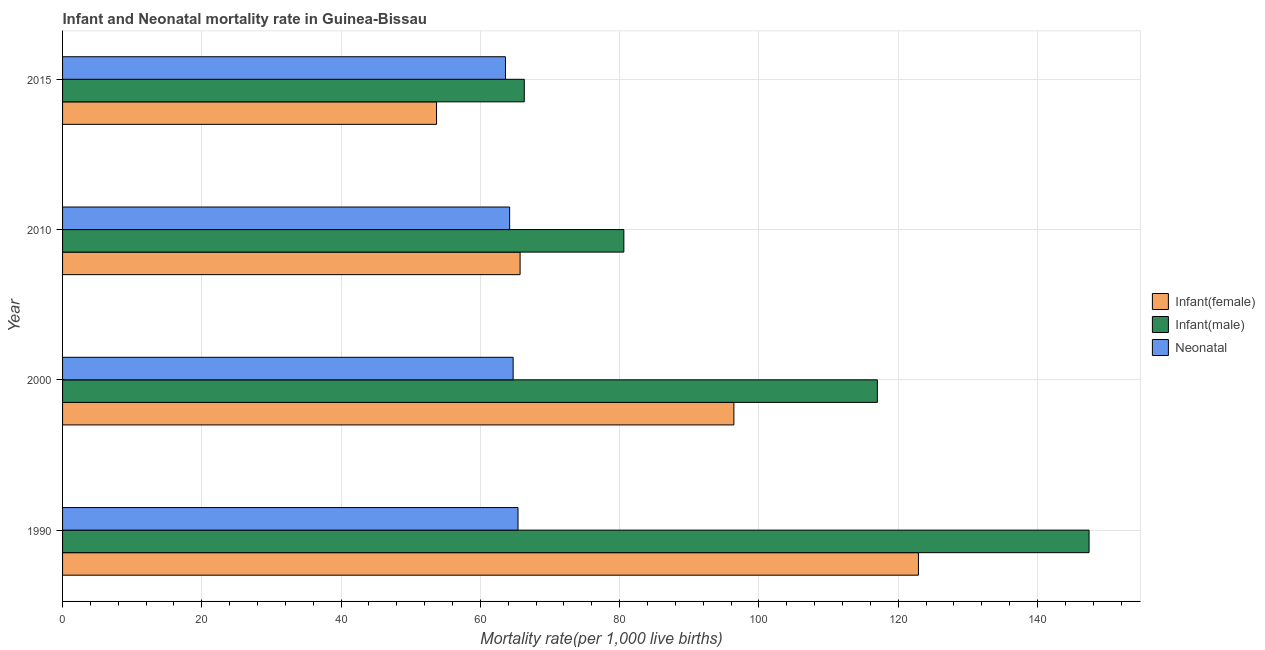How many different coloured bars are there?
Keep it short and to the point. 3. Are the number of bars on each tick of the Y-axis equal?
Provide a succinct answer. Yes. In how many cases, is the number of bars for a given year not equal to the number of legend labels?
Provide a succinct answer. 0. What is the neonatal mortality rate in 2010?
Your response must be concise. 64.2. Across all years, what is the maximum infant mortality rate(female)?
Keep it short and to the point. 122.9. Across all years, what is the minimum infant mortality rate(male)?
Keep it short and to the point. 66.3. In which year was the infant mortality rate(female) minimum?
Offer a very short reply. 2015. What is the total infant mortality rate(male) in the graph?
Give a very brief answer. 411.3. What is the difference between the infant mortality rate(male) in 1990 and that in 2000?
Your answer should be compact. 30.4. What is the difference between the infant mortality rate(male) in 1990 and the neonatal mortality rate in 2000?
Your response must be concise. 82.7. What is the average infant mortality rate(female) per year?
Provide a short and direct response. 84.67. In the year 2000, what is the difference between the neonatal mortality rate and infant mortality rate(male)?
Your response must be concise. -52.3. What is the ratio of the infant mortality rate(male) in 1990 to that in 2010?
Offer a very short reply. 1.83. Is the infant mortality rate(male) in 1990 less than that in 2010?
Your response must be concise. No. What is the difference between the highest and the lowest infant mortality rate(male)?
Make the answer very short. 81.1. In how many years, is the infant mortality rate(male) greater than the average infant mortality rate(male) taken over all years?
Make the answer very short. 2. What does the 1st bar from the top in 2010 represents?
Offer a very short reply. Neonatal . What does the 3rd bar from the bottom in 2000 represents?
Ensure brevity in your answer.  Neonatal . How many bars are there?
Your answer should be compact. 12. Are the values on the major ticks of X-axis written in scientific E-notation?
Offer a very short reply. No. Does the graph contain any zero values?
Offer a very short reply. No. Does the graph contain grids?
Keep it short and to the point. Yes. What is the title of the graph?
Ensure brevity in your answer.  Infant and Neonatal mortality rate in Guinea-Bissau. What is the label or title of the X-axis?
Your answer should be compact. Mortality rate(per 1,0 live births). What is the Mortality rate(per 1,000 live births) of Infant(female) in 1990?
Offer a very short reply. 122.9. What is the Mortality rate(per 1,000 live births) in Infant(male) in 1990?
Give a very brief answer. 147.4. What is the Mortality rate(per 1,000 live births) in Neonatal  in 1990?
Provide a short and direct response. 65.4. What is the Mortality rate(per 1,000 live births) in Infant(female) in 2000?
Your response must be concise. 96.4. What is the Mortality rate(per 1,000 live births) of Infant(male) in 2000?
Offer a terse response. 117. What is the Mortality rate(per 1,000 live births) in Neonatal  in 2000?
Make the answer very short. 64.7. What is the Mortality rate(per 1,000 live births) of Infant(female) in 2010?
Provide a succinct answer. 65.7. What is the Mortality rate(per 1,000 live births) of Infant(male) in 2010?
Your answer should be compact. 80.6. What is the Mortality rate(per 1,000 live births) of Neonatal  in 2010?
Ensure brevity in your answer.  64.2. What is the Mortality rate(per 1,000 live births) in Infant(female) in 2015?
Your answer should be compact. 53.7. What is the Mortality rate(per 1,000 live births) in Infant(male) in 2015?
Provide a succinct answer. 66.3. What is the Mortality rate(per 1,000 live births) of Neonatal  in 2015?
Make the answer very short. 63.6. Across all years, what is the maximum Mortality rate(per 1,000 live births) of Infant(female)?
Provide a succinct answer. 122.9. Across all years, what is the maximum Mortality rate(per 1,000 live births) of Infant(male)?
Keep it short and to the point. 147.4. Across all years, what is the maximum Mortality rate(per 1,000 live births) in Neonatal ?
Give a very brief answer. 65.4. Across all years, what is the minimum Mortality rate(per 1,000 live births) in Infant(female)?
Your answer should be compact. 53.7. Across all years, what is the minimum Mortality rate(per 1,000 live births) in Infant(male)?
Give a very brief answer. 66.3. Across all years, what is the minimum Mortality rate(per 1,000 live births) of Neonatal ?
Offer a terse response. 63.6. What is the total Mortality rate(per 1,000 live births) of Infant(female) in the graph?
Offer a terse response. 338.7. What is the total Mortality rate(per 1,000 live births) in Infant(male) in the graph?
Offer a very short reply. 411.3. What is the total Mortality rate(per 1,000 live births) in Neonatal  in the graph?
Your answer should be compact. 257.9. What is the difference between the Mortality rate(per 1,000 live births) in Infant(male) in 1990 and that in 2000?
Your answer should be compact. 30.4. What is the difference between the Mortality rate(per 1,000 live births) of Neonatal  in 1990 and that in 2000?
Give a very brief answer. 0.7. What is the difference between the Mortality rate(per 1,000 live births) of Infant(female) in 1990 and that in 2010?
Your answer should be compact. 57.2. What is the difference between the Mortality rate(per 1,000 live births) of Infant(male) in 1990 and that in 2010?
Give a very brief answer. 66.8. What is the difference between the Mortality rate(per 1,000 live births) in Infant(female) in 1990 and that in 2015?
Offer a very short reply. 69.2. What is the difference between the Mortality rate(per 1,000 live births) of Infant(male) in 1990 and that in 2015?
Your response must be concise. 81.1. What is the difference between the Mortality rate(per 1,000 live births) of Neonatal  in 1990 and that in 2015?
Offer a terse response. 1.8. What is the difference between the Mortality rate(per 1,000 live births) of Infant(female) in 2000 and that in 2010?
Offer a very short reply. 30.7. What is the difference between the Mortality rate(per 1,000 live births) in Infant(male) in 2000 and that in 2010?
Ensure brevity in your answer.  36.4. What is the difference between the Mortality rate(per 1,000 live births) in Neonatal  in 2000 and that in 2010?
Provide a succinct answer. 0.5. What is the difference between the Mortality rate(per 1,000 live births) in Infant(female) in 2000 and that in 2015?
Give a very brief answer. 42.7. What is the difference between the Mortality rate(per 1,000 live births) in Infant(male) in 2000 and that in 2015?
Ensure brevity in your answer.  50.7. What is the difference between the Mortality rate(per 1,000 live births) of Neonatal  in 2000 and that in 2015?
Make the answer very short. 1.1. What is the difference between the Mortality rate(per 1,000 live births) in Infant(female) in 2010 and that in 2015?
Give a very brief answer. 12. What is the difference between the Mortality rate(per 1,000 live births) in Infant(female) in 1990 and the Mortality rate(per 1,000 live births) in Neonatal  in 2000?
Offer a very short reply. 58.2. What is the difference between the Mortality rate(per 1,000 live births) of Infant(male) in 1990 and the Mortality rate(per 1,000 live births) of Neonatal  in 2000?
Your response must be concise. 82.7. What is the difference between the Mortality rate(per 1,000 live births) of Infant(female) in 1990 and the Mortality rate(per 1,000 live births) of Infant(male) in 2010?
Offer a very short reply. 42.3. What is the difference between the Mortality rate(per 1,000 live births) of Infant(female) in 1990 and the Mortality rate(per 1,000 live births) of Neonatal  in 2010?
Provide a succinct answer. 58.7. What is the difference between the Mortality rate(per 1,000 live births) in Infant(male) in 1990 and the Mortality rate(per 1,000 live births) in Neonatal  in 2010?
Provide a short and direct response. 83.2. What is the difference between the Mortality rate(per 1,000 live births) of Infant(female) in 1990 and the Mortality rate(per 1,000 live births) of Infant(male) in 2015?
Give a very brief answer. 56.6. What is the difference between the Mortality rate(per 1,000 live births) of Infant(female) in 1990 and the Mortality rate(per 1,000 live births) of Neonatal  in 2015?
Provide a succinct answer. 59.3. What is the difference between the Mortality rate(per 1,000 live births) in Infant(male) in 1990 and the Mortality rate(per 1,000 live births) in Neonatal  in 2015?
Your answer should be very brief. 83.8. What is the difference between the Mortality rate(per 1,000 live births) of Infant(female) in 2000 and the Mortality rate(per 1,000 live births) of Infant(male) in 2010?
Your answer should be compact. 15.8. What is the difference between the Mortality rate(per 1,000 live births) of Infant(female) in 2000 and the Mortality rate(per 1,000 live births) of Neonatal  in 2010?
Your response must be concise. 32.2. What is the difference between the Mortality rate(per 1,000 live births) of Infant(male) in 2000 and the Mortality rate(per 1,000 live births) of Neonatal  in 2010?
Keep it short and to the point. 52.8. What is the difference between the Mortality rate(per 1,000 live births) of Infant(female) in 2000 and the Mortality rate(per 1,000 live births) of Infant(male) in 2015?
Provide a succinct answer. 30.1. What is the difference between the Mortality rate(per 1,000 live births) of Infant(female) in 2000 and the Mortality rate(per 1,000 live births) of Neonatal  in 2015?
Offer a terse response. 32.8. What is the difference between the Mortality rate(per 1,000 live births) of Infant(male) in 2000 and the Mortality rate(per 1,000 live births) of Neonatal  in 2015?
Make the answer very short. 53.4. What is the difference between the Mortality rate(per 1,000 live births) in Infant(female) in 2010 and the Mortality rate(per 1,000 live births) in Infant(male) in 2015?
Provide a short and direct response. -0.6. What is the difference between the Mortality rate(per 1,000 live births) in Infant(female) in 2010 and the Mortality rate(per 1,000 live births) in Neonatal  in 2015?
Provide a succinct answer. 2.1. What is the average Mortality rate(per 1,000 live births) in Infant(female) per year?
Offer a terse response. 84.67. What is the average Mortality rate(per 1,000 live births) of Infant(male) per year?
Give a very brief answer. 102.83. What is the average Mortality rate(per 1,000 live births) of Neonatal  per year?
Offer a terse response. 64.47. In the year 1990, what is the difference between the Mortality rate(per 1,000 live births) of Infant(female) and Mortality rate(per 1,000 live births) of Infant(male)?
Make the answer very short. -24.5. In the year 1990, what is the difference between the Mortality rate(per 1,000 live births) of Infant(female) and Mortality rate(per 1,000 live births) of Neonatal ?
Keep it short and to the point. 57.5. In the year 2000, what is the difference between the Mortality rate(per 1,000 live births) of Infant(female) and Mortality rate(per 1,000 live births) of Infant(male)?
Ensure brevity in your answer.  -20.6. In the year 2000, what is the difference between the Mortality rate(per 1,000 live births) in Infant(female) and Mortality rate(per 1,000 live births) in Neonatal ?
Your answer should be compact. 31.7. In the year 2000, what is the difference between the Mortality rate(per 1,000 live births) in Infant(male) and Mortality rate(per 1,000 live births) in Neonatal ?
Your answer should be compact. 52.3. In the year 2010, what is the difference between the Mortality rate(per 1,000 live births) of Infant(female) and Mortality rate(per 1,000 live births) of Infant(male)?
Provide a short and direct response. -14.9. In the year 2015, what is the difference between the Mortality rate(per 1,000 live births) in Infant(female) and Mortality rate(per 1,000 live births) in Neonatal ?
Offer a very short reply. -9.9. What is the ratio of the Mortality rate(per 1,000 live births) of Infant(female) in 1990 to that in 2000?
Offer a very short reply. 1.27. What is the ratio of the Mortality rate(per 1,000 live births) in Infant(male) in 1990 to that in 2000?
Your response must be concise. 1.26. What is the ratio of the Mortality rate(per 1,000 live births) of Neonatal  in 1990 to that in 2000?
Make the answer very short. 1.01. What is the ratio of the Mortality rate(per 1,000 live births) of Infant(female) in 1990 to that in 2010?
Provide a succinct answer. 1.87. What is the ratio of the Mortality rate(per 1,000 live births) in Infant(male) in 1990 to that in 2010?
Ensure brevity in your answer.  1.83. What is the ratio of the Mortality rate(per 1,000 live births) of Neonatal  in 1990 to that in 2010?
Offer a terse response. 1.02. What is the ratio of the Mortality rate(per 1,000 live births) in Infant(female) in 1990 to that in 2015?
Your answer should be compact. 2.29. What is the ratio of the Mortality rate(per 1,000 live births) in Infant(male) in 1990 to that in 2015?
Make the answer very short. 2.22. What is the ratio of the Mortality rate(per 1,000 live births) in Neonatal  in 1990 to that in 2015?
Offer a very short reply. 1.03. What is the ratio of the Mortality rate(per 1,000 live births) in Infant(female) in 2000 to that in 2010?
Offer a very short reply. 1.47. What is the ratio of the Mortality rate(per 1,000 live births) of Infant(male) in 2000 to that in 2010?
Offer a terse response. 1.45. What is the ratio of the Mortality rate(per 1,000 live births) in Infant(female) in 2000 to that in 2015?
Your answer should be very brief. 1.8. What is the ratio of the Mortality rate(per 1,000 live births) in Infant(male) in 2000 to that in 2015?
Give a very brief answer. 1.76. What is the ratio of the Mortality rate(per 1,000 live births) in Neonatal  in 2000 to that in 2015?
Ensure brevity in your answer.  1.02. What is the ratio of the Mortality rate(per 1,000 live births) of Infant(female) in 2010 to that in 2015?
Give a very brief answer. 1.22. What is the ratio of the Mortality rate(per 1,000 live births) of Infant(male) in 2010 to that in 2015?
Give a very brief answer. 1.22. What is the ratio of the Mortality rate(per 1,000 live births) in Neonatal  in 2010 to that in 2015?
Keep it short and to the point. 1.01. What is the difference between the highest and the second highest Mortality rate(per 1,000 live births) in Infant(male)?
Keep it short and to the point. 30.4. What is the difference between the highest and the second highest Mortality rate(per 1,000 live births) of Neonatal ?
Your answer should be compact. 0.7. What is the difference between the highest and the lowest Mortality rate(per 1,000 live births) in Infant(female)?
Your answer should be compact. 69.2. What is the difference between the highest and the lowest Mortality rate(per 1,000 live births) in Infant(male)?
Give a very brief answer. 81.1. What is the difference between the highest and the lowest Mortality rate(per 1,000 live births) in Neonatal ?
Your response must be concise. 1.8. 